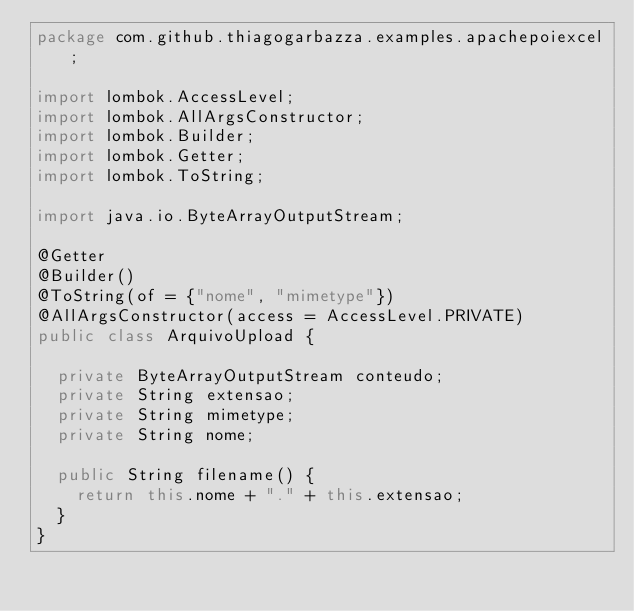Convert code to text. <code><loc_0><loc_0><loc_500><loc_500><_Java_>package com.github.thiagogarbazza.examples.apachepoiexcel;

import lombok.AccessLevel;
import lombok.AllArgsConstructor;
import lombok.Builder;
import lombok.Getter;
import lombok.ToString;

import java.io.ByteArrayOutputStream;

@Getter
@Builder()
@ToString(of = {"nome", "mimetype"})
@AllArgsConstructor(access = AccessLevel.PRIVATE)
public class ArquivoUpload {

  private ByteArrayOutputStream conteudo;
  private String extensao;
  private String mimetype;
  private String nome;

  public String filename() {
    return this.nome + "." + this.extensao;
  }
}
</code> 